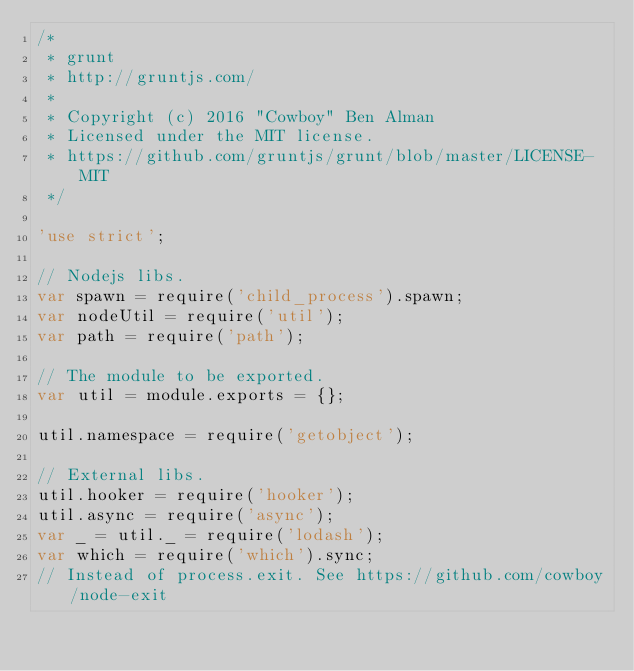<code> <loc_0><loc_0><loc_500><loc_500><_JavaScript_>/*
 * grunt
 * http://gruntjs.com/
 *
 * Copyright (c) 2016 "Cowboy" Ben Alman
 * Licensed under the MIT license.
 * https://github.com/gruntjs/grunt/blob/master/LICENSE-MIT
 */

'use strict';

// Nodejs libs.
var spawn = require('child_process').spawn;
var nodeUtil = require('util');
var path = require('path');

// The module to be exported.
var util = module.exports = {};

util.namespace = require('getobject');

// External libs.
util.hooker = require('hooker');
util.async = require('async');
var _ = util._ = require('lodash');
var which = require('which').sync;
// Instead of process.exit. See https://github.com/cowboy/node-exit</code> 